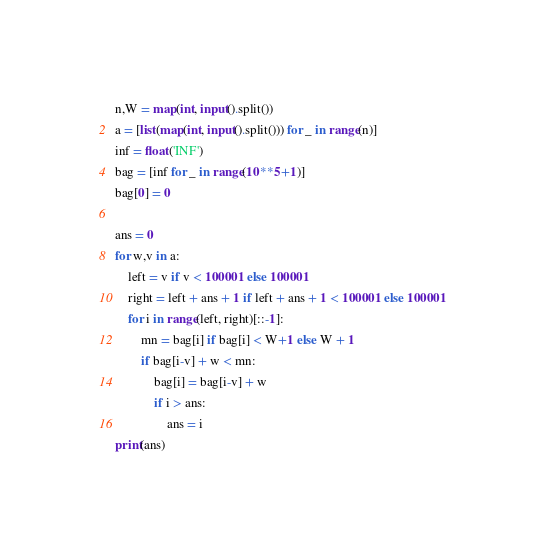Convert code to text. <code><loc_0><loc_0><loc_500><loc_500><_Python_>n,W = map(int, input().split())
a = [list(map(int, input().split())) for _ in range(n)]
inf = float('INF')
bag = [inf for _ in range(10**5+1)]
bag[0] = 0

ans = 0
for w,v in a:
    left = v if v < 100001 else 100001
    right = left + ans + 1 if left + ans + 1 < 100001 else 100001
    for i in range(left, right)[::-1]:
        mn = bag[i] if bag[i] < W+1 else W + 1
        if bag[i-v] + w < mn:
            bag[i] = bag[i-v] + w
            if i > ans:
                ans = i
print(ans)
</code> 